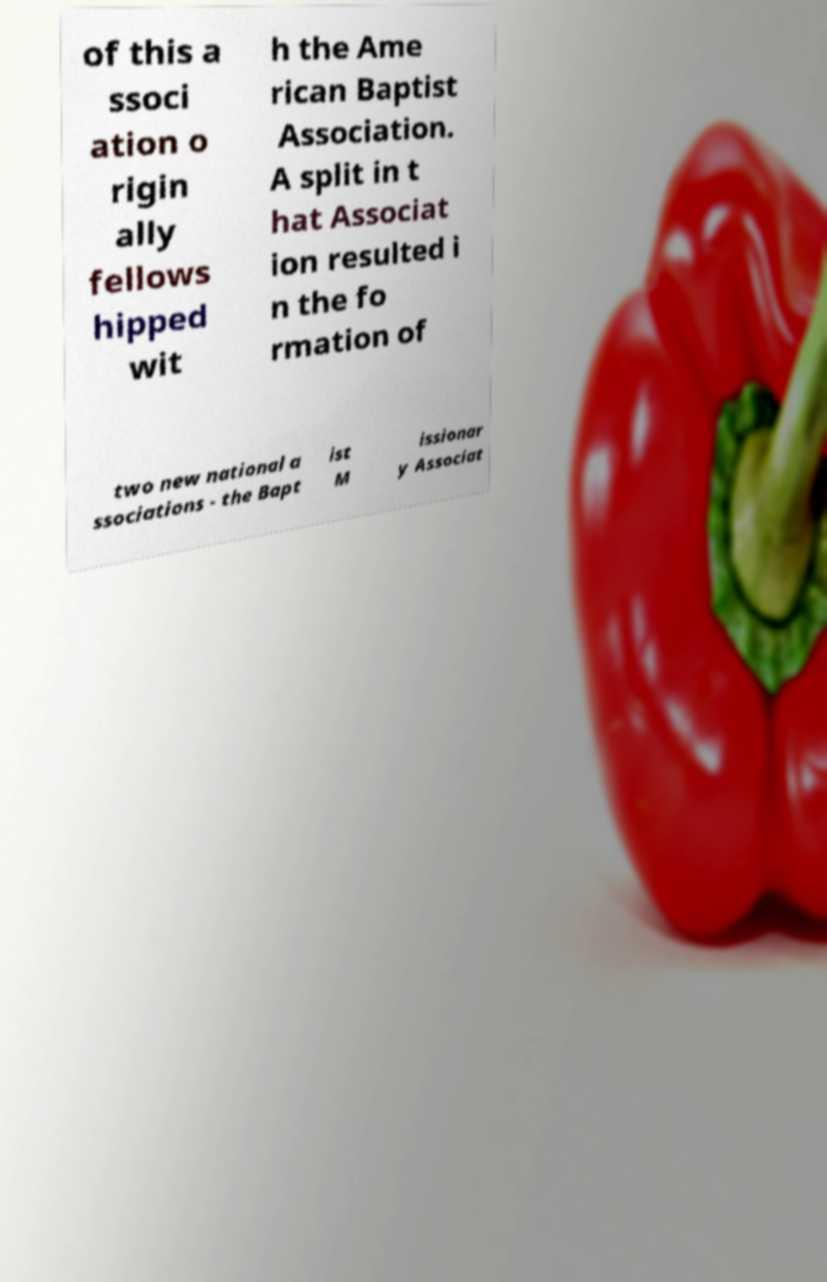Could you assist in decoding the text presented in this image and type it out clearly? of this a ssoci ation o rigin ally fellows hipped wit h the Ame rican Baptist Association. A split in t hat Associat ion resulted i n the fo rmation of two new national a ssociations - the Bapt ist M issionar y Associat 